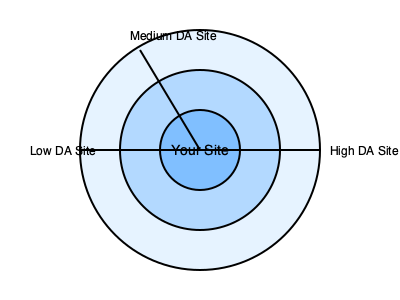Analisando o diagrama de rede de backlinks acima, qual estratégia provavelmente teria o maior impacto positivo na autoridade de domínio do site central? Para responder a esta questão, vamos analisar o diagrama e considerar os princípios de SEO relacionados à autoridade de domínio:

1. O diagrama mostra um site central ("Your Site") conectado a três outros sites com diferentes níveis de autoridade de domínio (DA).

2. Os círculos concêntricos em torno do site central podem representar níveis de influência ou proximidade na rede de links.

3. As conexões (linhas) representam backlinks de outros sites para o site central.

4. Observamos três tipos de sites ligados ao site central:
   a. Um site de alta DA (High DA Site)
   b. Um site de média DA (Medium DA Site)
   c. Um site de baixa DA (Low DA Site)

5. Em SEO, backlinks de sites com maior autoridade de domínio geralmente transferem mais "valor" ou "autoridade" para o site que recebe o link.

6. A estratégia de obter backlinks de sites com alta autoridade de domínio é geralmente considerada mais eficaz para aumentar a própria autoridade de domínio de um site.

7. Portanto, focar em obter mais backlinks de sites com alta DA seria provavelmente a estratégia mais impactante para melhorar a autoridade de domínio do site central.

8. Isso não significa que backlinks de sites de média ou baixa DA devam ser ignorados, pois uma mistura diversificada de backlinks é importante para um perfil de links natural e saudável.

Considerando esses fatores, a estratégia que provavelmente teria o maior impacto positivo na autoridade de domínio do site central seria focar em obter mais backlinks de sites com alta autoridade de domínio.
Answer: Obter mais backlinks de sites com alta autoridade de domínio. 